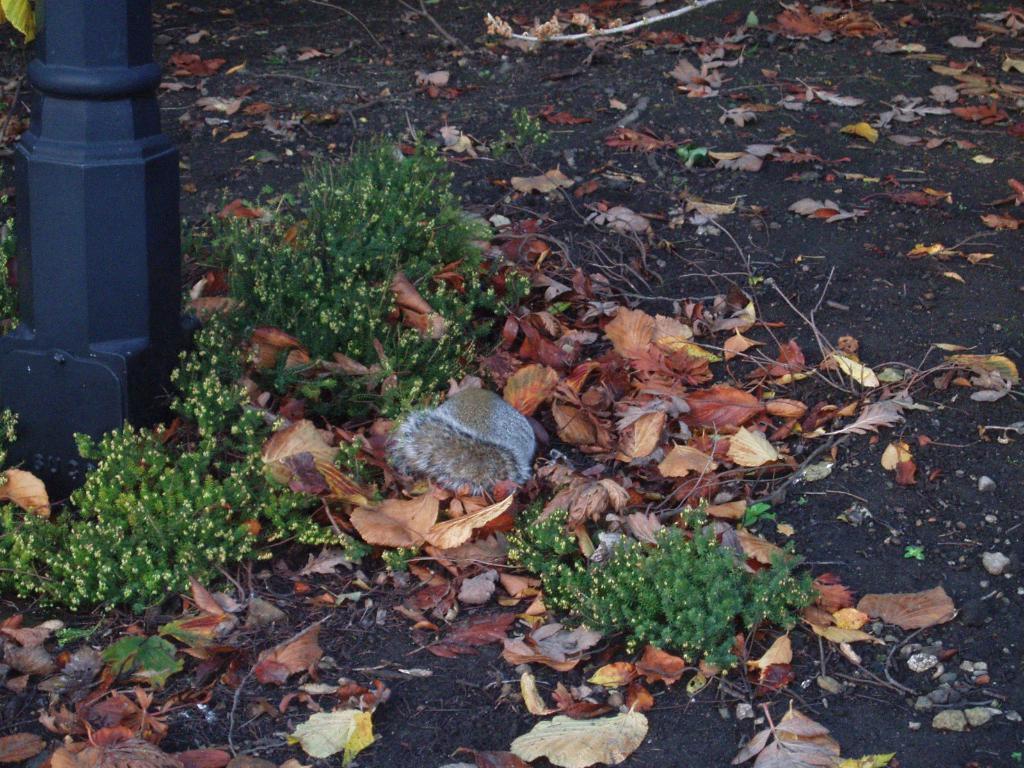How would you summarize this image in a sentence or two? In this image there are plants, pole. At the bottom of the image there are dried leaves and some other object on the surface. 